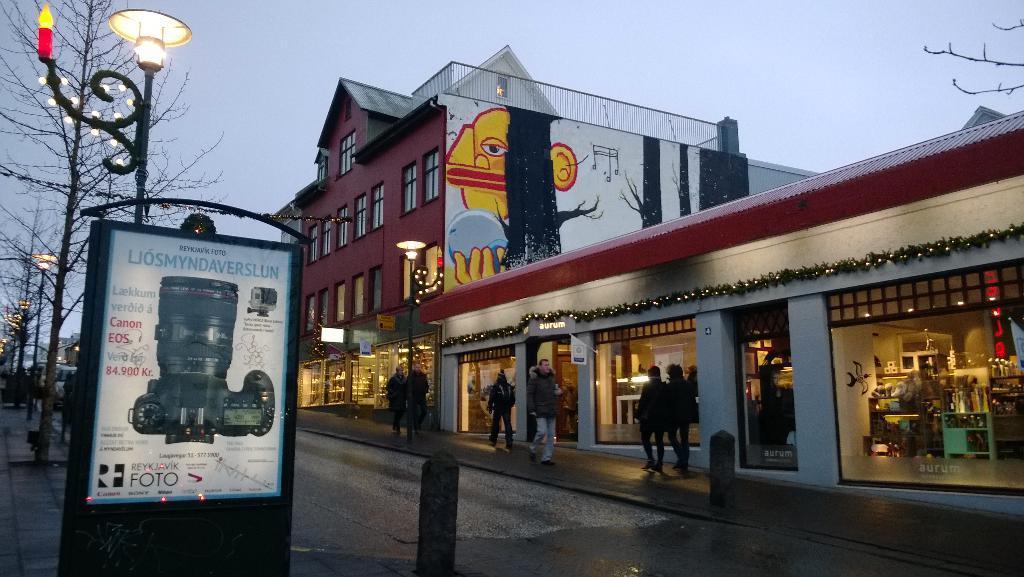In one or two sentences, can you explain what this image depicts? In this image there is the sky towards the top of the image, there are buildings towards the right of the image, there are persons walking, there is a painting on the wall, there is road towards the bottom of the image, there is a board towards the bottom of the image, there is text on the board, there are poles, there are lights, there are trees towards the left of the image, there is an object towards the bottom of the image. 